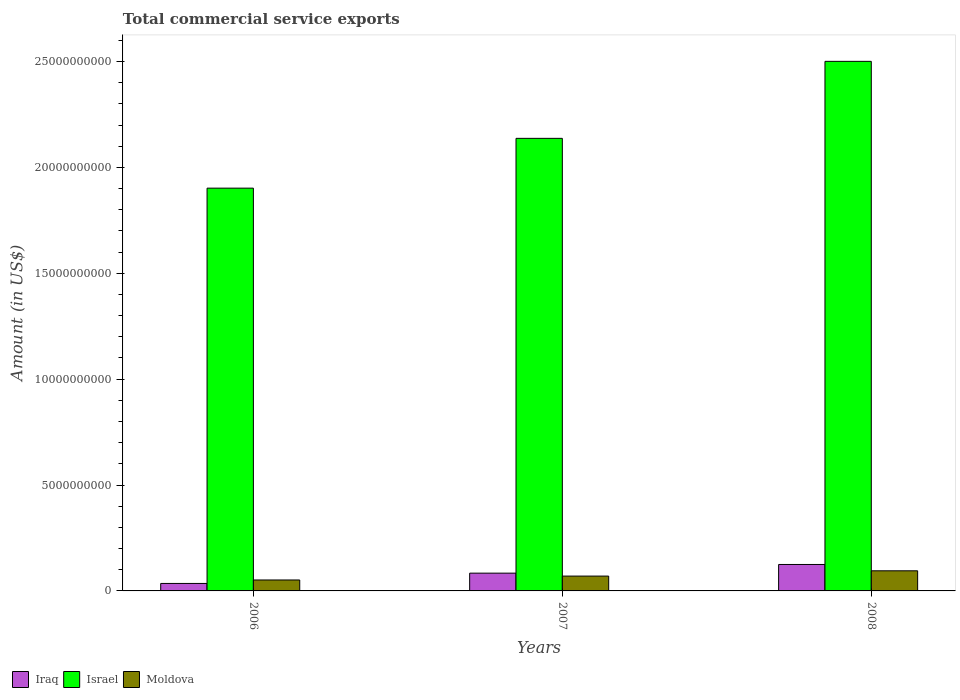How many different coloured bars are there?
Your response must be concise. 3. How many groups of bars are there?
Give a very brief answer. 3. Are the number of bars per tick equal to the number of legend labels?
Provide a succinct answer. Yes. Are the number of bars on each tick of the X-axis equal?
Ensure brevity in your answer.  Yes. How many bars are there on the 1st tick from the left?
Ensure brevity in your answer.  3. What is the label of the 3rd group of bars from the left?
Make the answer very short. 2008. In how many cases, is the number of bars for a given year not equal to the number of legend labels?
Ensure brevity in your answer.  0. What is the total commercial service exports in Iraq in 2006?
Your response must be concise. 3.53e+08. Across all years, what is the maximum total commercial service exports in Israel?
Your answer should be very brief. 2.50e+1. Across all years, what is the minimum total commercial service exports in Iraq?
Offer a very short reply. 3.53e+08. In which year was the total commercial service exports in Iraq minimum?
Keep it short and to the point. 2006. What is the total total commercial service exports in Iraq in the graph?
Give a very brief answer. 2.44e+09. What is the difference between the total commercial service exports in Iraq in 2006 and that in 2008?
Your answer should be compact. -8.96e+08. What is the difference between the total commercial service exports in Iraq in 2007 and the total commercial service exports in Moldova in 2006?
Your answer should be compact. 3.22e+08. What is the average total commercial service exports in Israel per year?
Keep it short and to the point. 2.18e+1. In the year 2008, what is the difference between the total commercial service exports in Iraq and total commercial service exports in Israel?
Offer a terse response. -2.38e+1. In how many years, is the total commercial service exports in Israel greater than 3000000000 US$?
Offer a very short reply. 3. What is the ratio of the total commercial service exports in Moldova in 2006 to that in 2008?
Offer a very short reply. 0.54. What is the difference between the highest and the second highest total commercial service exports in Israel?
Provide a succinct answer. 3.64e+09. What is the difference between the highest and the lowest total commercial service exports in Iraq?
Provide a succinct answer. 8.96e+08. In how many years, is the total commercial service exports in Iraq greater than the average total commercial service exports in Iraq taken over all years?
Offer a terse response. 2. Is the sum of the total commercial service exports in Moldova in 2006 and 2007 greater than the maximum total commercial service exports in Iraq across all years?
Give a very brief answer. No. What does the 2nd bar from the left in 2007 represents?
Ensure brevity in your answer.  Israel. What does the 3rd bar from the right in 2006 represents?
Your answer should be very brief. Iraq. How many bars are there?
Ensure brevity in your answer.  9. Are all the bars in the graph horizontal?
Offer a terse response. No. How many years are there in the graph?
Your response must be concise. 3. What is the difference between two consecutive major ticks on the Y-axis?
Provide a succinct answer. 5.00e+09. Where does the legend appear in the graph?
Provide a short and direct response. Bottom left. How many legend labels are there?
Ensure brevity in your answer.  3. What is the title of the graph?
Your response must be concise. Total commercial service exports. Does "Hong Kong" appear as one of the legend labels in the graph?
Keep it short and to the point. No. What is the Amount (in US$) in Iraq in 2006?
Your answer should be very brief. 3.53e+08. What is the Amount (in US$) of Israel in 2006?
Ensure brevity in your answer.  1.90e+1. What is the Amount (in US$) of Moldova in 2006?
Offer a very short reply. 5.17e+08. What is the Amount (in US$) of Iraq in 2007?
Provide a succinct answer. 8.39e+08. What is the Amount (in US$) in Israel in 2007?
Ensure brevity in your answer.  2.14e+1. What is the Amount (in US$) in Moldova in 2007?
Keep it short and to the point. 7.00e+08. What is the Amount (in US$) of Iraq in 2008?
Ensure brevity in your answer.  1.25e+09. What is the Amount (in US$) in Israel in 2008?
Offer a terse response. 2.50e+1. What is the Amount (in US$) of Moldova in 2008?
Provide a short and direct response. 9.50e+08. Across all years, what is the maximum Amount (in US$) of Iraq?
Your answer should be compact. 1.25e+09. Across all years, what is the maximum Amount (in US$) of Israel?
Provide a short and direct response. 2.50e+1. Across all years, what is the maximum Amount (in US$) in Moldova?
Your answer should be compact. 9.50e+08. Across all years, what is the minimum Amount (in US$) of Iraq?
Offer a terse response. 3.53e+08. Across all years, what is the minimum Amount (in US$) of Israel?
Provide a short and direct response. 1.90e+1. Across all years, what is the minimum Amount (in US$) of Moldova?
Ensure brevity in your answer.  5.17e+08. What is the total Amount (in US$) in Iraq in the graph?
Your answer should be very brief. 2.44e+09. What is the total Amount (in US$) of Israel in the graph?
Your answer should be compact. 6.54e+1. What is the total Amount (in US$) in Moldova in the graph?
Your answer should be compact. 2.17e+09. What is the difference between the Amount (in US$) in Iraq in 2006 and that in 2007?
Offer a terse response. -4.86e+08. What is the difference between the Amount (in US$) in Israel in 2006 and that in 2007?
Keep it short and to the point. -2.35e+09. What is the difference between the Amount (in US$) of Moldova in 2006 and that in 2007?
Your answer should be compact. -1.84e+08. What is the difference between the Amount (in US$) in Iraq in 2006 and that in 2008?
Make the answer very short. -8.96e+08. What is the difference between the Amount (in US$) of Israel in 2006 and that in 2008?
Offer a very short reply. -5.99e+09. What is the difference between the Amount (in US$) in Moldova in 2006 and that in 2008?
Your answer should be very brief. -4.33e+08. What is the difference between the Amount (in US$) of Iraq in 2007 and that in 2008?
Provide a short and direct response. -4.10e+08. What is the difference between the Amount (in US$) of Israel in 2007 and that in 2008?
Provide a succinct answer. -3.64e+09. What is the difference between the Amount (in US$) of Moldova in 2007 and that in 2008?
Make the answer very short. -2.50e+08. What is the difference between the Amount (in US$) in Iraq in 2006 and the Amount (in US$) in Israel in 2007?
Ensure brevity in your answer.  -2.10e+1. What is the difference between the Amount (in US$) of Iraq in 2006 and the Amount (in US$) of Moldova in 2007?
Ensure brevity in your answer.  -3.47e+08. What is the difference between the Amount (in US$) of Israel in 2006 and the Amount (in US$) of Moldova in 2007?
Make the answer very short. 1.83e+1. What is the difference between the Amount (in US$) of Iraq in 2006 and the Amount (in US$) of Israel in 2008?
Your response must be concise. -2.47e+1. What is the difference between the Amount (in US$) in Iraq in 2006 and the Amount (in US$) in Moldova in 2008?
Provide a short and direct response. -5.97e+08. What is the difference between the Amount (in US$) in Israel in 2006 and the Amount (in US$) in Moldova in 2008?
Offer a very short reply. 1.81e+1. What is the difference between the Amount (in US$) of Iraq in 2007 and the Amount (in US$) of Israel in 2008?
Give a very brief answer. -2.42e+1. What is the difference between the Amount (in US$) in Iraq in 2007 and the Amount (in US$) in Moldova in 2008?
Keep it short and to the point. -1.11e+08. What is the difference between the Amount (in US$) of Israel in 2007 and the Amount (in US$) of Moldova in 2008?
Your answer should be compact. 2.04e+1. What is the average Amount (in US$) in Iraq per year?
Give a very brief answer. 8.14e+08. What is the average Amount (in US$) of Israel per year?
Keep it short and to the point. 2.18e+1. What is the average Amount (in US$) of Moldova per year?
Provide a succinct answer. 7.22e+08. In the year 2006, what is the difference between the Amount (in US$) in Iraq and Amount (in US$) in Israel?
Your response must be concise. -1.87e+1. In the year 2006, what is the difference between the Amount (in US$) of Iraq and Amount (in US$) of Moldova?
Offer a very short reply. -1.64e+08. In the year 2006, what is the difference between the Amount (in US$) in Israel and Amount (in US$) in Moldova?
Provide a short and direct response. 1.85e+1. In the year 2007, what is the difference between the Amount (in US$) of Iraq and Amount (in US$) of Israel?
Provide a short and direct response. -2.05e+1. In the year 2007, what is the difference between the Amount (in US$) of Iraq and Amount (in US$) of Moldova?
Make the answer very short. 1.39e+08. In the year 2007, what is the difference between the Amount (in US$) in Israel and Amount (in US$) in Moldova?
Provide a short and direct response. 2.07e+1. In the year 2008, what is the difference between the Amount (in US$) in Iraq and Amount (in US$) in Israel?
Offer a terse response. -2.38e+1. In the year 2008, what is the difference between the Amount (in US$) in Iraq and Amount (in US$) in Moldova?
Your answer should be very brief. 2.99e+08. In the year 2008, what is the difference between the Amount (in US$) in Israel and Amount (in US$) in Moldova?
Provide a short and direct response. 2.41e+1. What is the ratio of the Amount (in US$) in Iraq in 2006 to that in 2007?
Keep it short and to the point. 0.42. What is the ratio of the Amount (in US$) of Israel in 2006 to that in 2007?
Offer a terse response. 0.89. What is the ratio of the Amount (in US$) in Moldova in 2006 to that in 2007?
Your response must be concise. 0.74. What is the ratio of the Amount (in US$) of Iraq in 2006 to that in 2008?
Provide a short and direct response. 0.28. What is the ratio of the Amount (in US$) in Israel in 2006 to that in 2008?
Provide a short and direct response. 0.76. What is the ratio of the Amount (in US$) in Moldova in 2006 to that in 2008?
Ensure brevity in your answer.  0.54. What is the ratio of the Amount (in US$) in Iraq in 2007 to that in 2008?
Provide a short and direct response. 0.67. What is the ratio of the Amount (in US$) of Israel in 2007 to that in 2008?
Offer a very short reply. 0.85. What is the ratio of the Amount (in US$) of Moldova in 2007 to that in 2008?
Ensure brevity in your answer.  0.74. What is the difference between the highest and the second highest Amount (in US$) of Iraq?
Offer a terse response. 4.10e+08. What is the difference between the highest and the second highest Amount (in US$) of Israel?
Provide a short and direct response. 3.64e+09. What is the difference between the highest and the second highest Amount (in US$) of Moldova?
Offer a terse response. 2.50e+08. What is the difference between the highest and the lowest Amount (in US$) in Iraq?
Your response must be concise. 8.96e+08. What is the difference between the highest and the lowest Amount (in US$) of Israel?
Ensure brevity in your answer.  5.99e+09. What is the difference between the highest and the lowest Amount (in US$) of Moldova?
Make the answer very short. 4.33e+08. 